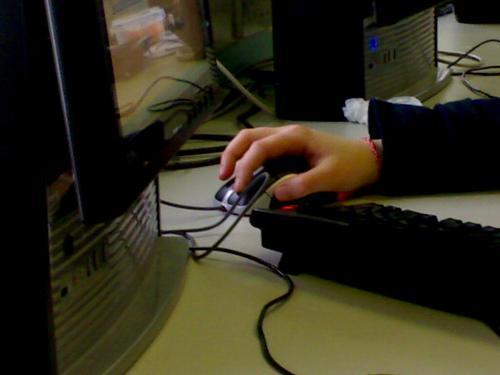How many hands do you see?
Give a very brief answer. 1. 